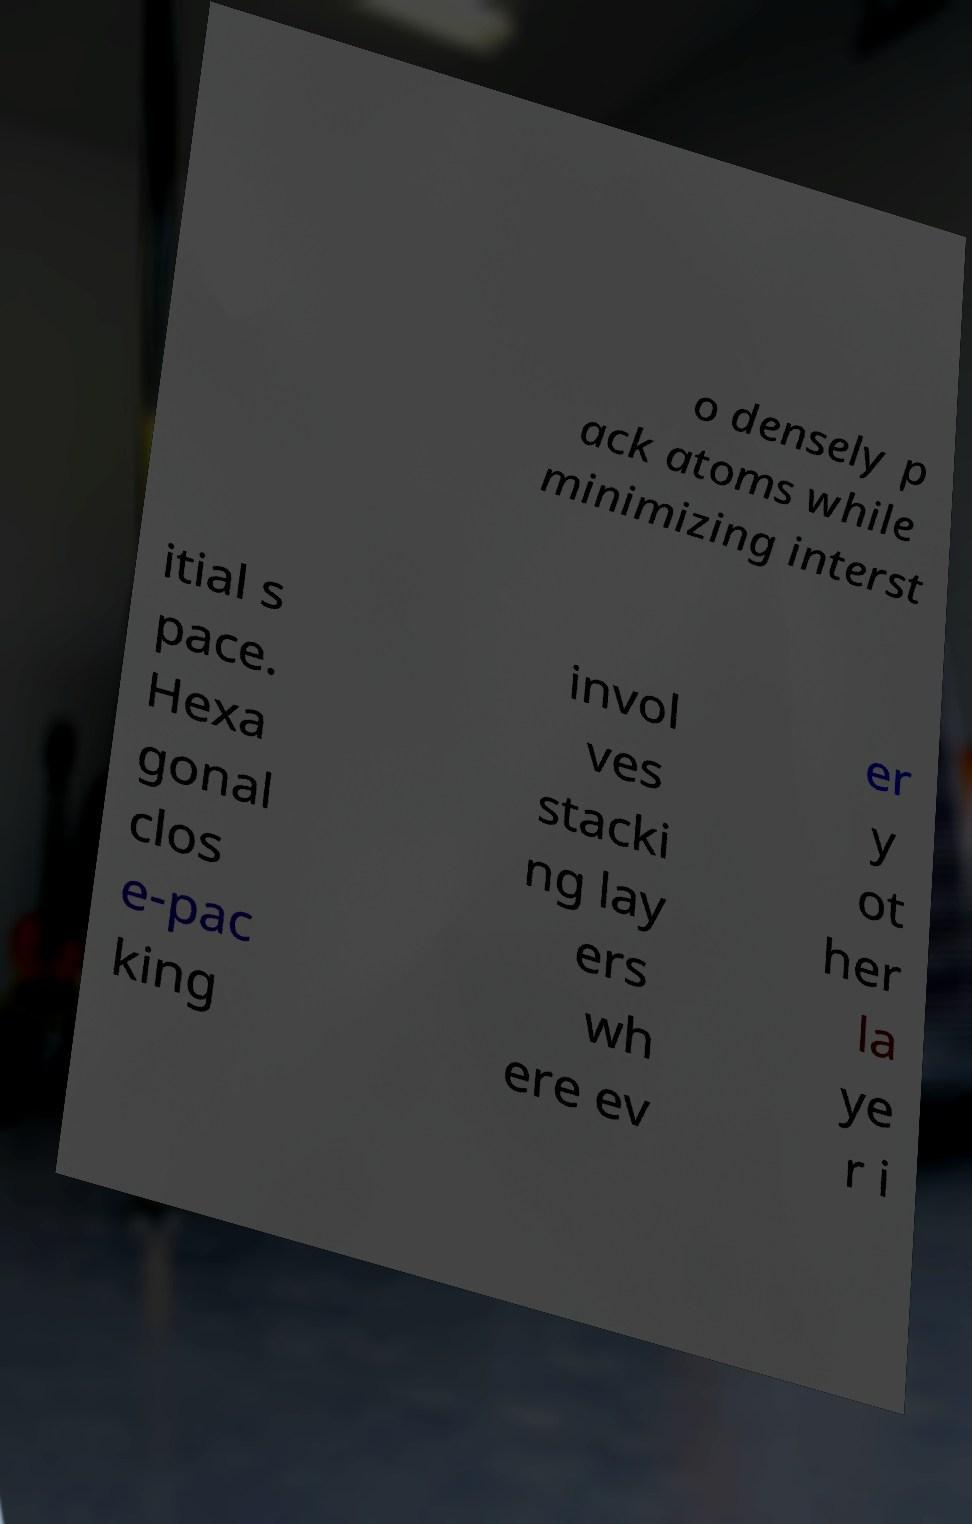What messages or text are displayed in this image? I need them in a readable, typed format. o densely p ack atoms while minimizing interst itial s pace. Hexa gonal clos e-pac king invol ves stacki ng lay ers wh ere ev er y ot her la ye r i 